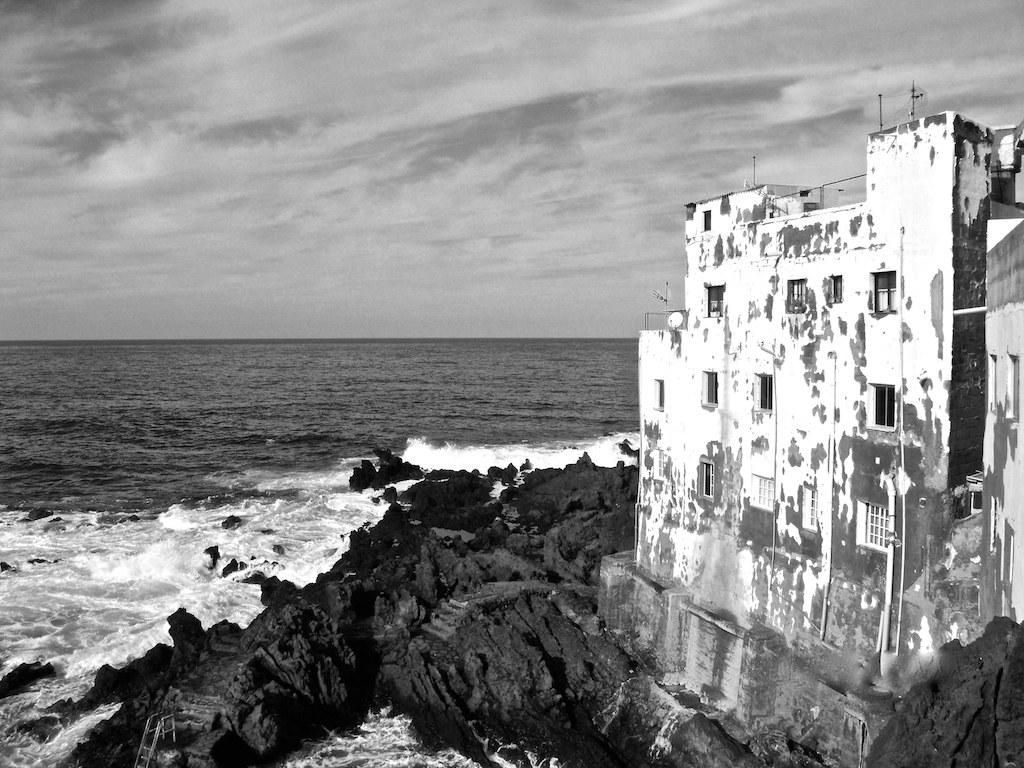What is the color scheme of the image? The image is black and white. What natural element can be seen in the image? There is water visible in the image. What man-made structure is present in the image? There is a building in the image. What type of geological feature is present in the image? Rocks are present in the image. What is the condition of the sky in the image? The sky appears to be cloudy in the image. Can you describe the unspecified "things" in the image? Unfortunately, the provided facts do not give any specific details about the "things" in the image. Can you tell me how many rifles are visible in the image? There are no rifles present in the image. What type of thrill can be experienced by the objects in the image? There are no objects in the image that can experience a thrill, as the image features natural and man-made elements. --- Facts: 1. There is a person in the image. 2. The person is wearing a hat. 3. The person is holding a book. 4. There is a tree in the background of the image. 5. The ground is visible in the image. Absurd Topics: parrot, sand, umbrella Conversation: Who is present in the image? There is a person in the image. What is the person wearing? The person is wearing a hat. What is the person holding? The person is holding a book. What can be seen in the background of the image? There is a tree in the background of the image. What is visible on the ground in the image? The ground is visible in the image. Reasoning: Let's think step by step in order to produce the conversation. We start by identifying the main subject in the image, which is the person. Then, we describe the person's clothing and what they are holding, which is a hat and a book, respectively. Next, we mention the background element, which is a tree. Finally, we acknowledge the presence of the ground in the image. Absurd Question/Answer: What type of parrot is perched on the person's shoulder in the image? There is no parrot present in the image. What type of sand can be seen on the ground in the image? There is no sand visible on the ground in the image. 